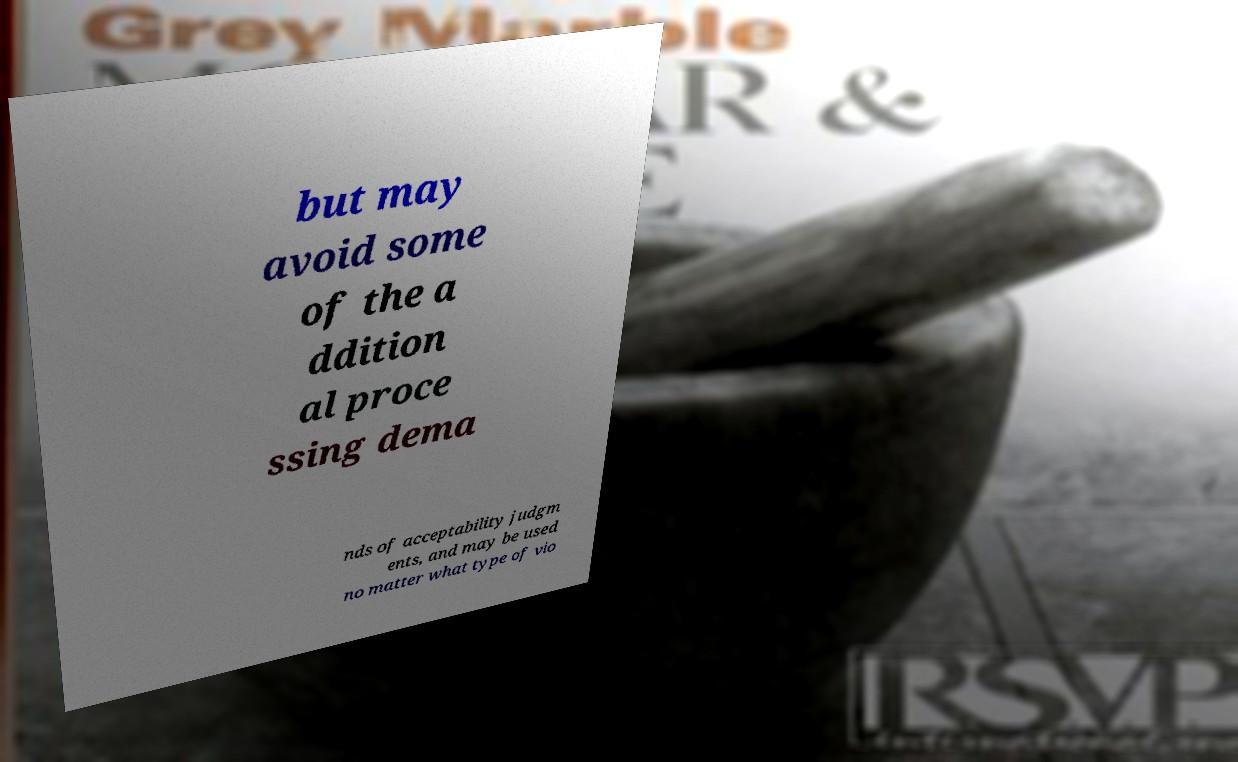Please read and relay the text visible in this image. What does it say? but may avoid some of the a ddition al proce ssing dema nds of acceptability judgm ents, and may be used no matter what type of vio 